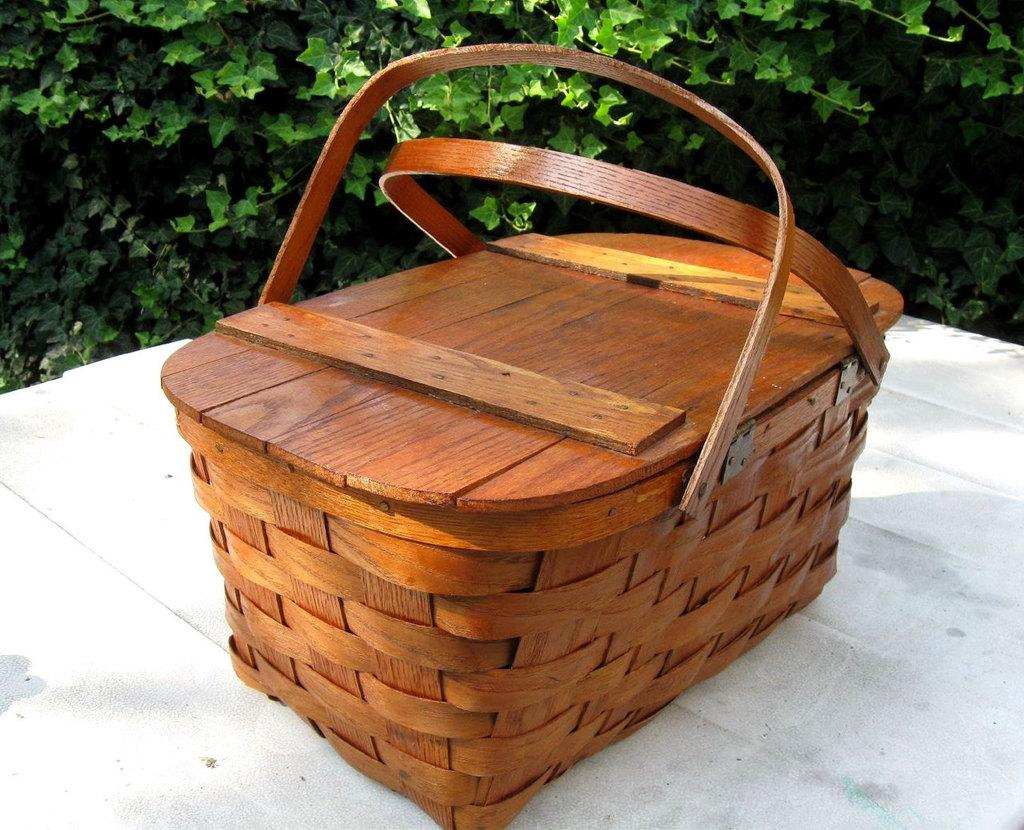What type of container is present in the image? There is a brown basket with a lid in the image. Where is the brown basket located? The brown basket is placed on a white table. What else can be seen in the image besides the brown basket? There are plants visible in the image. What is the color of the plants in the image? The plants are green in color. What type of voice can be heard coming from the plants in the image? There is no voice coming from the plants in the image, as plants do not have the ability to produce sound. 